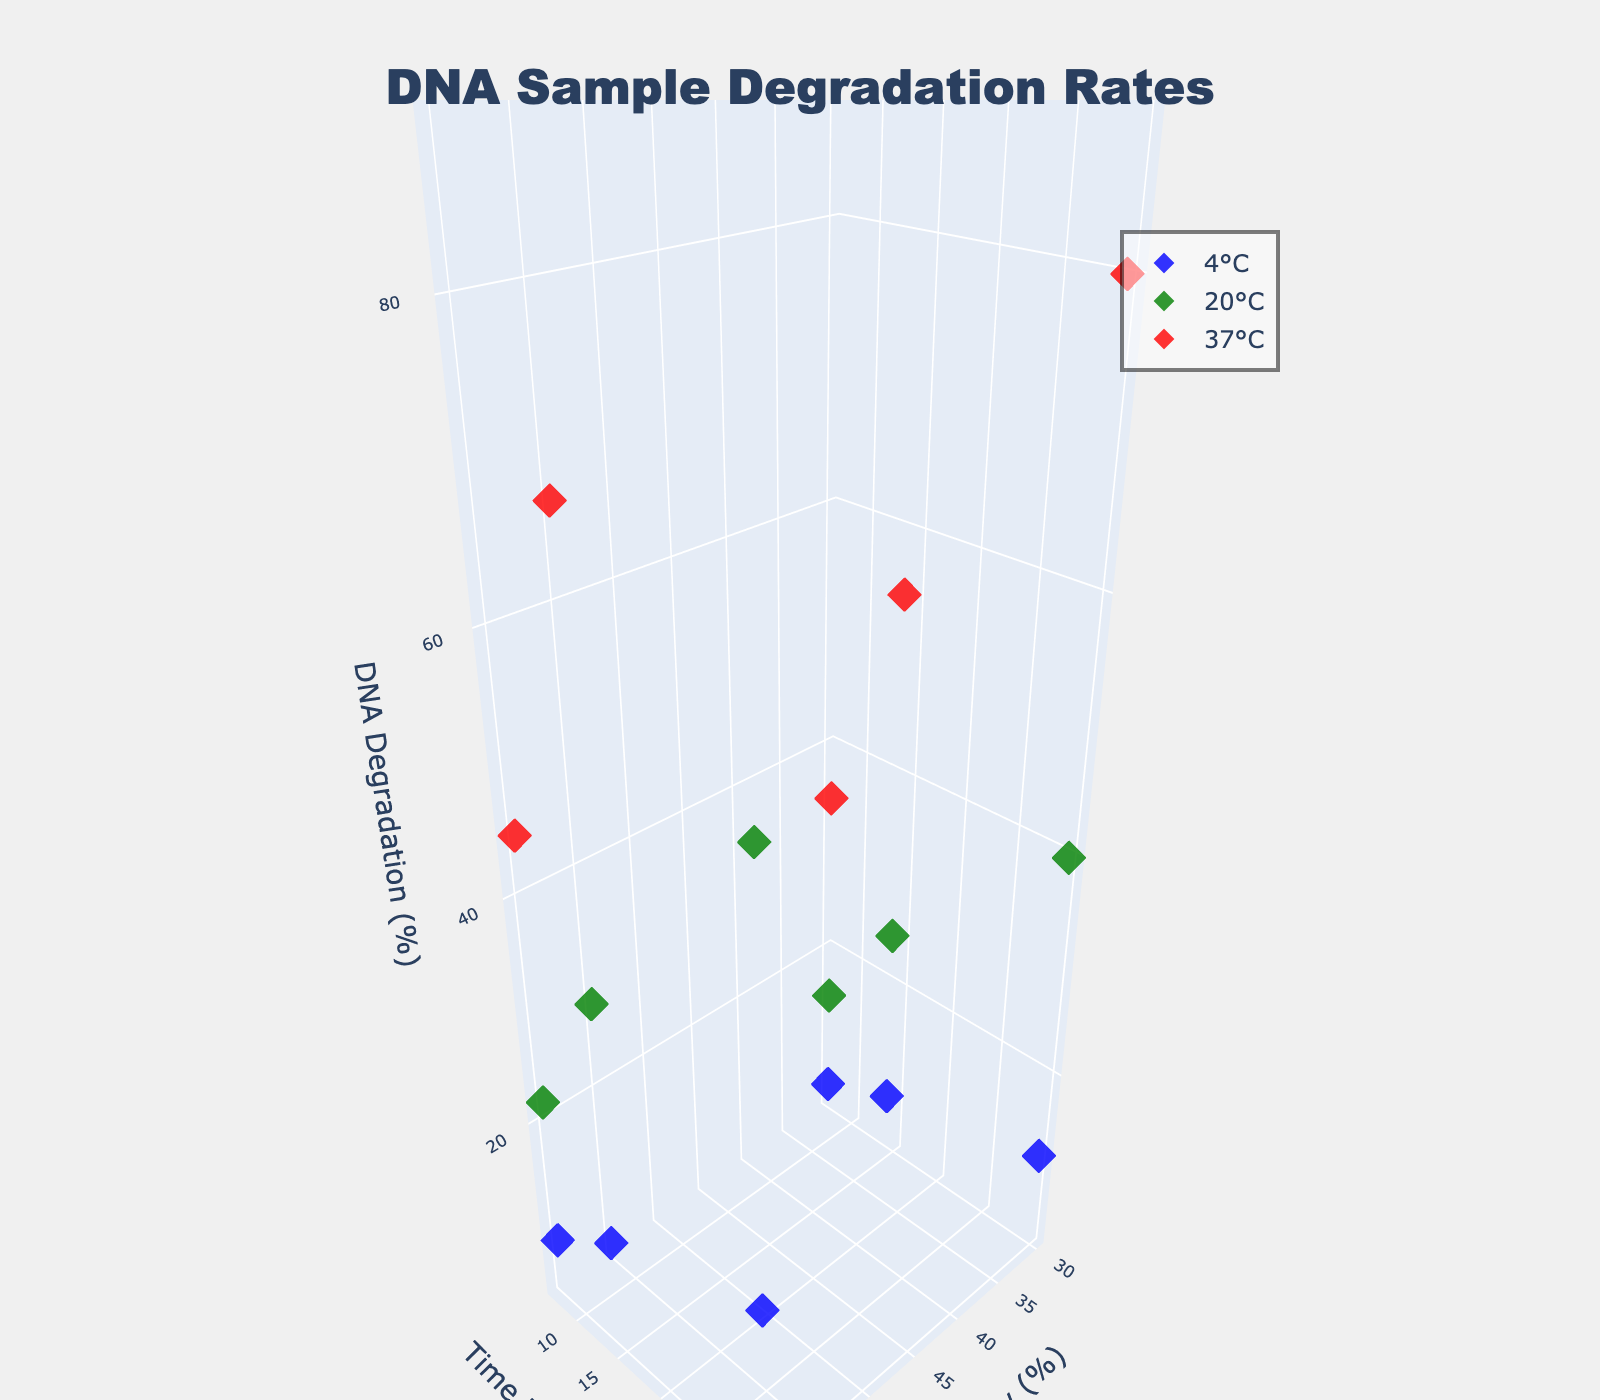What is the title of the figure? The title is located at the top center of the figure and states "DNA Sample Degradation Rates"
Answer: DNA Sample Degradation Rates Which axis represents time elapsed? The axis titles indicate that the y-axis represents "Time Elapsed (days)," which is located on the vertical dimension.
Answer: y-axis How many unique temperatures are shown in the plot? There are three unique temperatures shown, each represented by a different color: blue for 4°C, green for 20°C, and red for 37°C.
Answer: 3 Which temperature condition has the highest DNA degradation at the maximum time elapsed? At 37°C (red points), the highest DNA degradation is observed at 70-95% after 30 days.
Answer: 37°C At 20°C and 60% humidity, how has the DNA degradation rate changed from day 7 to day 30? At 20°C and 60% humidity, the DNA degradation rate increases from 22% on day 7 to 55% on day 30. The difference is 55% - 22% = 33%.
Answer: Increased by 33% For temperatures 4°C, 20°C, and 37°C, which temperature shows the slowest rate of DNA degradation over time? The plot shows that 4°C (blue points) has the slowest rate of DNA degradation over time compared to 20°C and 37°C.
Answer: 4°C What trend can you observe in DNA degradation when comparing 30% and 60% humidity across all time points for a specific temperature? DNA degradation rates are higher at 60% humidity compared to 30% humidity, regardless of temperature and time points.
Answer: Higher at 60% How does DNA degradation at 37°C compare to 4°C after 14 days under 30% humidity? After 14 days under 30% humidity, DNA degradation at 37°C is 55%, whereas at 4°C, it is 8%. Thus, degradation at 37°C is significantly higher.
Answer: 55% vs 8% What is the effect of humidity level changes on DNA degradation at constant 20°C after 14 days? At a constant 20°C after 14 days, increasing humidity from 30% to 60% increases DNA degradation from 25% to 35%.
Answer: Increased by 10% Which data point represents the highest DNA degradation observed in the study, and under what conditions? The highest DNA degradation observed is 95%, which occurs at 37°C and 60% humidity after 30 days.
Answer: 95%, 37°C, 60% humidity, 30 days 